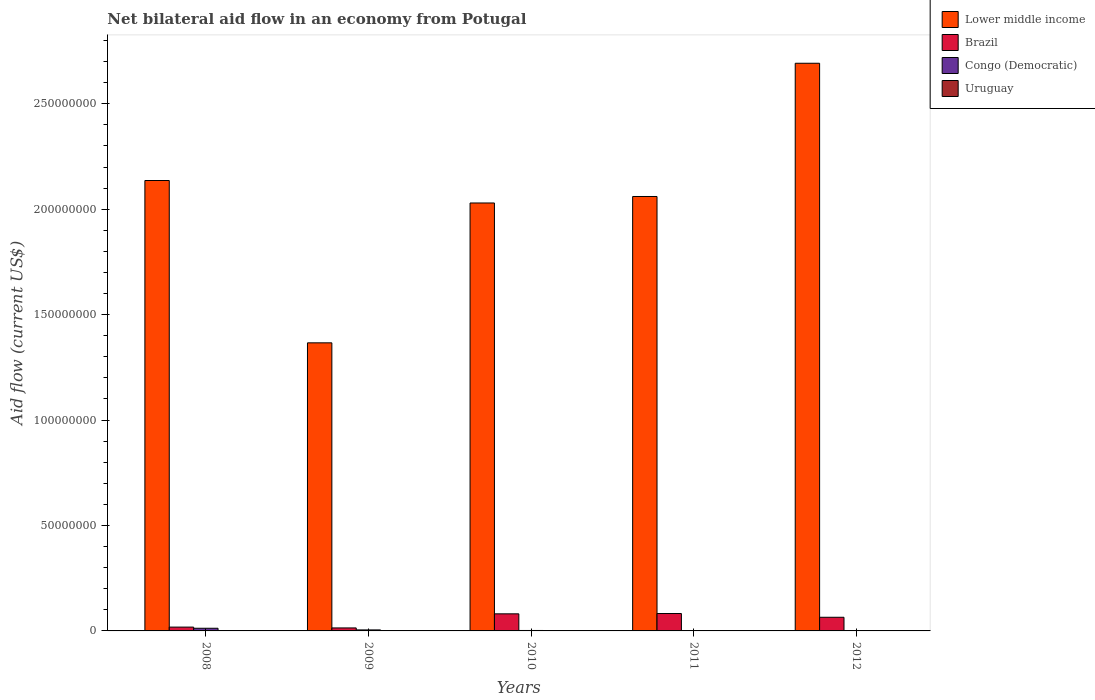How many different coloured bars are there?
Make the answer very short. 4. Are the number of bars on each tick of the X-axis equal?
Keep it short and to the point. Yes. How many bars are there on the 4th tick from the left?
Make the answer very short. 4. How many bars are there on the 3rd tick from the right?
Your response must be concise. 4. In how many cases, is the number of bars for a given year not equal to the number of legend labels?
Provide a succinct answer. 0. What is the net bilateral aid flow in Brazil in 2008?
Your response must be concise. 1.81e+06. Across all years, what is the maximum net bilateral aid flow in Congo (Democratic)?
Provide a short and direct response. 1.26e+06. In which year was the net bilateral aid flow in Congo (Democratic) maximum?
Your answer should be very brief. 2008. What is the total net bilateral aid flow in Uruguay in the graph?
Ensure brevity in your answer.  3.70e+05. What is the difference between the net bilateral aid flow in Lower middle income in 2008 and that in 2010?
Your response must be concise. 1.07e+07. What is the difference between the net bilateral aid flow in Lower middle income in 2008 and the net bilateral aid flow in Brazil in 2010?
Make the answer very short. 2.06e+08. What is the average net bilateral aid flow in Brazil per year?
Offer a very short reply. 5.21e+06. In the year 2011, what is the difference between the net bilateral aid flow in Uruguay and net bilateral aid flow in Lower middle income?
Offer a terse response. -2.06e+08. What is the ratio of the net bilateral aid flow in Lower middle income in 2011 to that in 2012?
Ensure brevity in your answer.  0.77. What is the difference between the highest and the second highest net bilateral aid flow in Uruguay?
Give a very brief answer. 2.00e+04. Is it the case that in every year, the sum of the net bilateral aid flow in Lower middle income and net bilateral aid flow in Uruguay is greater than the sum of net bilateral aid flow in Congo (Democratic) and net bilateral aid flow in Brazil?
Offer a terse response. No. What does the 3rd bar from the left in 2011 represents?
Make the answer very short. Congo (Democratic). What does the 1st bar from the right in 2009 represents?
Provide a succinct answer. Uruguay. Are all the bars in the graph horizontal?
Offer a terse response. No. How many years are there in the graph?
Ensure brevity in your answer.  5. What is the difference between two consecutive major ticks on the Y-axis?
Keep it short and to the point. 5.00e+07. Are the values on the major ticks of Y-axis written in scientific E-notation?
Provide a succinct answer. No. Does the graph contain any zero values?
Keep it short and to the point. No. Does the graph contain grids?
Offer a very short reply. No. How many legend labels are there?
Your answer should be very brief. 4. What is the title of the graph?
Ensure brevity in your answer.  Net bilateral aid flow in an economy from Potugal. Does "Sierra Leone" appear as one of the legend labels in the graph?
Your answer should be compact. No. What is the label or title of the X-axis?
Give a very brief answer. Years. What is the Aid flow (current US$) of Lower middle income in 2008?
Offer a terse response. 2.14e+08. What is the Aid flow (current US$) of Brazil in 2008?
Provide a succinct answer. 1.81e+06. What is the Aid flow (current US$) of Congo (Democratic) in 2008?
Provide a short and direct response. 1.26e+06. What is the Aid flow (current US$) of Lower middle income in 2009?
Give a very brief answer. 1.37e+08. What is the Aid flow (current US$) of Brazil in 2009?
Your answer should be compact. 1.42e+06. What is the Aid flow (current US$) of Congo (Democratic) in 2009?
Keep it short and to the point. 4.80e+05. What is the Aid flow (current US$) of Uruguay in 2009?
Your answer should be very brief. 6.00e+04. What is the Aid flow (current US$) in Lower middle income in 2010?
Provide a succinct answer. 2.03e+08. What is the Aid flow (current US$) in Brazil in 2010?
Your answer should be compact. 8.10e+06. What is the Aid flow (current US$) of Lower middle income in 2011?
Your response must be concise. 2.06e+08. What is the Aid flow (current US$) in Brazil in 2011?
Your answer should be very brief. 8.25e+06. What is the Aid flow (current US$) of Uruguay in 2011?
Ensure brevity in your answer.  9.00e+04. What is the Aid flow (current US$) of Lower middle income in 2012?
Make the answer very short. 2.69e+08. What is the Aid flow (current US$) of Brazil in 2012?
Make the answer very short. 6.47e+06. What is the Aid flow (current US$) in Uruguay in 2012?
Offer a very short reply. 7.00e+04. Across all years, what is the maximum Aid flow (current US$) in Lower middle income?
Give a very brief answer. 2.69e+08. Across all years, what is the maximum Aid flow (current US$) in Brazil?
Provide a short and direct response. 8.25e+06. Across all years, what is the maximum Aid flow (current US$) of Congo (Democratic)?
Your answer should be compact. 1.26e+06. Across all years, what is the maximum Aid flow (current US$) in Uruguay?
Your response must be concise. 1.10e+05. Across all years, what is the minimum Aid flow (current US$) in Lower middle income?
Your answer should be compact. 1.37e+08. Across all years, what is the minimum Aid flow (current US$) of Brazil?
Keep it short and to the point. 1.42e+06. Across all years, what is the minimum Aid flow (current US$) of Congo (Democratic)?
Keep it short and to the point. 3.00e+04. What is the total Aid flow (current US$) of Lower middle income in the graph?
Keep it short and to the point. 1.03e+09. What is the total Aid flow (current US$) of Brazil in the graph?
Offer a very short reply. 2.60e+07. What is the total Aid flow (current US$) in Congo (Democratic) in the graph?
Your answer should be very brief. 2.02e+06. What is the difference between the Aid flow (current US$) of Lower middle income in 2008 and that in 2009?
Offer a very short reply. 7.70e+07. What is the difference between the Aid flow (current US$) of Brazil in 2008 and that in 2009?
Make the answer very short. 3.90e+05. What is the difference between the Aid flow (current US$) in Congo (Democratic) in 2008 and that in 2009?
Your answer should be very brief. 7.80e+05. What is the difference between the Aid flow (current US$) of Uruguay in 2008 and that in 2009?
Your answer should be very brief. 5.00e+04. What is the difference between the Aid flow (current US$) in Lower middle income in 2008 and that in 2010?
Provide a succinct answer. 1.07e+07. What is the difference between the Aid flow (current US$) of Brazil in 2008 and that in 2010?
Ensure brevity in your answer.  -6.29e+06. What is the difference between the Aid flow (current US$) in Congo (Democratic) in 2008 and that in 2010?
Offer a very short reply. 1.05e+06. What is the difference between the Aid flow (current US$) in Lower middle income in 2008 and that in 2011?
Provide a succinct answer. 7.58e+06. What is the difference between the Aid flow (current US$) of Brazil in 2008 and that in 2011?
Ensure brevity in your answer.  -6.44e+06. What is the difference between the Aid flow (current US$) in Congo (Democratic) in 2008 and that in 2011?
Provide a succinct answer. 1.23e+06. What is the difference between the Aid flow (current US$) of Uruguay in 2008 and that in 2011?
Your answer should be compact. 2.00e+04. What is the difference between the Aid flow (current US$) in Lower middle income in 2008 and that in 2012?
Provide a succinct answer. -5.56e+07. What is the difference between the Aid flow (current US$) in Brazil in 2008 and that in 2012?
Give a very brief answer. -4.66e+06. What is the difference between the Aid flow (current US$) of Congo (Democratic) in 2008 and that in 2012?
Ensure brevity in your answer.  1.22e+06. What is the difference between the Aid flow (current US$) in Uruguay in 2008 and that in 2012?
Make the answer very short. 4.00e+04. What is the difference between the Aid flow (current US$) in Lower middle income in 2009 and that in 2010?
Your response must be concise. -6.63e+07. What is the difference between the Aid flow (current US$) in Brazil in 2009 and that in 2010?
Offer a very short reply. -6.68e+06. What is the difference between the Aid flow (current US$) in Uruguay in 2009 and that in 2010?
Make the answer very short. 2.00e+04. What is the difference between the Aid flow (current US$) of Lower middle income in 2009 and that in 2011?
Provide a short and direct response. -6.94e+07. What is the difference between the Aid flow (current US$) of Brazil in 2009 and that in 2011?
Your answer should be compact. -6.83e+06. What is the difference between the Aid flow (current US$) of Congo (Democratic) in 2009 and that in 2011?
Provide a short and direct response. 4.50e+05. What is the difference between the Aid flow (current US$) of Lower middle income in 2009 and that in 2012?
Your answer should be very brief. -1.33e+08. What is the difference between the Aid flow (current US$) in Brazil in 2009 and that in 2012?
Keep it short and to the point. -5.05e+06. What is the difference between the Aid flow (current US$) of Lower middle income in 2010 and that in 2011?
Make the answer very short. -3.08e+06. What is the difference between the Aid flow (current US$) in Lower middle income in 2010 and that in 2012?
Offer a terse response. -6.63e+07. What is the difference between the Aid flow (current US$) of Brazil in 2010 and that in 2012?
Ensure brevity in your answer.  1.63e+06. What is the difference between the Aid flow (current US$) in Congo (Democratic) in 2010 and that in 2012?
Your answer should be very brief. 1.70e+05. What is the difference between the Aid flow (current US$) in Uruguay in 2010 and that in 2012?
Give a very brief answer. -3.00e+04. What is the difference between the Aid flow (current US$) in Lower middle income in 2011 and that in 2012?
Keep it short and to the point. -6.32e+07. What is the difference between the Aid flow (current US$) of Brazil in 2011 and that in 2012?
Keep it short and to the point. 1.78e+06. What is the difference between the Aid flow (current US$) of Congo (Democratic) in 2011 and that in 2012?
Provide a succinct answer. -10000. What is the difference between the Aid flow (current US$) of Uruguay in 2011 and that in 2012?
Provide a succinct answer. 2.00e+04. What is the difference between the Aid flow (current US$) in Lower middle income in 2008 and the Aid flow (current US$) in Brazil in 2009?
Make the answer very short. 2.12e+08. What is the difference between the Aid flow (current US$) of Lower middle income in 2008 and the Aid flow (current US$) of Congo (Democratic) in 2009?
Your response must be concise. 2.13e+08. What is the difference between the Aid flow (current US$) of Lower middle income in 2008 and the Aid flow (current US$) of Uruguay in 2009?
Give a very brief answer. 2.14e+08. What is the difference between the Aid flow (current US$) of Brazil in 2008 and the Aid flow (current US$) of Congo (Democratic) in 2009?
Offer a very short reply. 1.33e+06. What is the difference between the Aid flow (current US$) of Brazil in 2008 and the Aid flow (current US$) of Uruguay in 2009?
Your answer should be compact. 1.75e+06. What is the difference between the Aid flow (current US$) in Congo (Democratic) in 2008 and the Aid flow (current US$) in Uruguay in 2009?
Ensure brevity in your answer.  1.20e+06. What is the difference between the Aid flow (current US$) in Lower middle income in 2008 and the Aid flow (current US$) in Brazil in 2010?
Ensure brevity in your answer.  2.06e+08. What is the difference between the Aid flow (current US$) in Lower middle income in 2008 and the Aid flow (current US$) in Congo (Democratic) in 2010?
Offer a very short reply. 2.13e+08. What is the difference between the Aid flow (current US$) of Lower middle income in 2008 and the Aid flow (current US$) of Uruguay in 2010?
Your response must be concise. 2.14e+08. What is the difference between the Aid flow (current US$) in Brazil in 2008 and the Aid flow (current US$) in Congo (Democratic) in 2010?
Ensure brevity in your answer.  1.60e+06. What is the difference between the Aid flow (current US$) in Brazil in 2008 and the Aid flow (current US$) in Uruguay in 2010?
Keep it short and to the point. 1.77e+06. What is the difference between the Aid flow (current US$) of Congo (Democratic) in 2008 and the Aid flow (current US$) of Uruguay in 2010?
Your answer should be compact. 1.22e+06. What is the difference between the Aid flow (current US$) of Lower middle income in 2008 and the Aid flow (current US$) of Brazil in 2011?
Keep it short and to the point. 2.05e+08. What is the difference between the Aid flow (current US$) of Lower middle income in 2008 and the Aid flow (current US$) of Congo (Democratic) in 2011?
Offer a terse response. 2.14e+08. What is the difference between the Aid flow (current US$) of Lower middle income in 2008 and the Aid flow (current US$) of Uruguay in 2011?
Your answer should be very brief. 2.14e+08. What is the difference between the Aid flow (current US$) in Brazil in 2008 and the Aid flow (current US$) in Congo (Democratic) in 2011?
Give a very brief answer. 1.78e+06. What is the difference between the Aid flow (current US$) of Brazil in 2008 and the Aid flow (current US$) of Uruguay in 2011?
Offer a terse response. 1.72e+06. What is the difference between the Aid flow (current US$) of Congo (Democratic) in 2008 and the Aid flow (current US$) of Uruguay in 2011?
Make the answer very short. 1.17e+06. What is the difference between the Aid flow (current US$) of Lower middle income in 2008 and the Aid flow (current US$) of Brazil in 2012?
Your answer should be compact. 2.07e+08. What is the difference between the Aid flow (current US$) of Lower middle income in 2008 and the Aid flow (current US$) of Congo (Democratic) in 2012?
Make the answer very short. 2.14e+08. What is the difference between the Aid flow (current US$) of Lower middle income in 2008 and the Aid flow (current US$) of Uruguay in 2012?
Make the answer very short. 2.14e+08. What is the difference between the Aid flow (current US$) in Brazil in 2008 and the Aid flow (current US$) in Congo (Democratic) in 2012?
Offer a very short reply. 1.77e+06. What is the difference between the Aid flow (current US$) of Brazil in 2008 and the Aid flow (current US$) of Uruguay in 2012?
Offer a very short reply. 1.74e+06. What is the difference between the Aid flow (current US$) in Congo (Democratic) in 2008 and the Aid flow (current US$) in Uruguay in 2012?
Give a very brief answer. 1.19e+06. What is the difference between the Aid flow (current US$) in Lower middle income in 2009 and the Aid flow (current US$) in Brazil in 2010?
Offer a terse response. 1.29e+08. What is the difference between the Aid flow (current US$) in Lower middle income in 2009 and the Aid flow (current US$) in Congo (Democratic) in 2010?
Offer a terse response. 1.36e+08. What is the difference between the Aid flow (current US$) of Lower middle income in 2009 and the Aid flow (current US$) of Uruguay in 2010?
Ensure brevity in your answer.  1.37e+08. What is the difference between the Aid flow (current US$) of Brazil in 2009 and the Aid flow (current US$) of Congo (Democratic) in 2010?
Make the answer very short. 1.21e+06. What is the difference between the Aid flow (current US$) in Brazil in 2009 and the Aid flow (current US$) in Uruguay in 2010?
Your answer should be compact. 1.38e+06. What is the difference between the Aid flow (current US$) of Congo (Democratic) in 2009 and the Aid flow (current US$) of Uruguay in 2010?
Provide a succinct answer. 4.40e+05. What is the difference between the Aid flow (current US$) of Lower middle income in 2009 and the Aid flow (current US$) of Brazil in 2011?
Make the answer very short. 1.28e+08. What is the difference between the Aid flow (current US$) in Lower middle income in 2009 and the Aid flow (current US$) in Congo (Democratic) in 2011?
Your answer should be compact. 1.37e+08. What is the difference between the Aid flow (current US$) of Lower middle income in 2009 and the Aid flow (current US$) of Uruguay in 2011?
Your answer should be compact. 1.37e+08. What is the difference between the Aid flow (current US$) in Brazil in 2009 and the Aid flow (current US$) in Congo (Democratic) in 2011?
Make the answer very short. 1.39e+06. What is the difference between the Aid flow (current US$) in Brazil in 2009 and the Aid flow (current US$) in Uruguay in 2011?
Keep it short and to the point. 1.33e+06. What is the difference between the Aid flow (current US$) in Congo (Democratic) in 2009 and the Aid flow (current US$) in Uruguay in 2011?
Keep it short and to the point. 3.90e+05. What is the difference between the Aid flow (current US$) in Lower middle income in 2009 and the Aid flow (current US$) in Brazil in 2012?
Keep it short and to the point. 1.30e+08. What is the difference between the Aid flow (current US$) of Lower middle income in 2009 and the Aid flow (current US$) of Congo (Democratic) in 2012?
Keep it short and to the point. 1.37e+08. What is the difference between the Aid flow (current US$) of Lower middle income in 2009 and the Aid flow (current US$) of Uruguay in 2012?
Your response must be concise. 1.37e+08. What is the difference between the Aid flow (current US$) in Brazil in 2009 and the Aid flow (current US$) in Congo (Democratic) in 2012?
Offer a terse response. 1.38e+06. What is the difference between the Aid flow (current US$) in Brazil in 2009 and the Aid flow (current US$) in Uruguay in 2012?
Your answer should be very brief. 1.35e+06. What is the difference between the Aid flow (current US$) in Lower middle income in 2010 and the Aid flow (current US$) in Brazil in 2011?
Ensure brevity in your answer.  1.95e+08. What is the difference between the Aid flow (current US$) of Lower middle income in 2010 and the Aid flow (current US$) of Congo (Democratic) in 2011?
Your answer should be compact. 2.03e+08. What is the difference between the Aid flow (current US$) in Lower middle income in 2010 and the Aid flow (current US$) in Uruguay in 2011?
Make the answer very short. 2.03e+08. What is the difference between the Aid flow (current US$) of Brazil in 2010 and the Aid flow (current US$) of Congo (Democratic) in 2011?
Keep it short and to the point. 8.07e+06. What is the difference between the Aid flow (current US$) of Brazil in 2010 and the Aid flow (current US$) of Uruguay in 2011?
Ensure brevity in your answer.  8.01e+06. What is the difference between the Aid flow (current US$) of Congo (Democratic) in 2010 and the Aid flow (current US$) of Uruguay in 2011?
Your answer should be compact. 1.20e+05. What is the difference between the Aid flow (current US$) in Lower middle income in 2010 and the Aid flow (current US$) in Brazil in 2012?
Your answer should be compact. 1.96e+08. What is the difference between the Aid flow (current US$) of Lower middle income in 2010 and the Aid flow (current US$) of Congo (Democratic) in 2012?
Your response must be concise. 2.03e+08. What is the difference between the Aid flow (current US$) in Lower middle income in 2010 and the Aid flow (current US$) in Uruguay in 2012?
Ensure brevity in your answer.  2.03e+08. What is the difference between the Aid flow (current US$) of Brazil in 2010 and the Aid flow (current US$) of Congo (Democratic) in 2012?
Ensure brevity in your answer.  8.06e+06. What is the difference between the Aid flow (current US$) in Brazil in 2010 and the Aid flow (current US$) in Uruguay in 2012?
Keep it short and to the point. 8.03e+06. What is the difference between the Aid flow (current US$) in Lower middle income in 2011 and the Aid flow (current US$) in Brazil in 2012?
Keep it short and to the point. 2.00e+08. What is the difference between the Aid flow (current US$) of Lower middle income in 2011 and the Aid flow (current US$) of Congo (Democratic) in 2012?
Keep it short and to the point. 2.06e+08. What is the difference between the Aid flow (current US$) of Lower middle income in 2011 and the Aid flow (current US$) of Uruguay in 2012?
Keep it short and to the point. 2.06e+08. What is the difference between the Aid flow (current US$) of Brazil in 2011 and the Aid flow (current US$) of Congo (Democratic) in 2012?
Offer a very short reply. 8.21e+06. What is the difference between the Aid flow (current US$) of Brazil in 2011 and the Aid flow (current US$) of Uruguay in 2012?
Give a very brief answer. 8.18e+06. What is the difference between the Aid flow (current US$) in Congo (Democratic) in 2011 and the Aid flow (current US$) in Uruguay in 2012?
Your response must be concise. -4.00e+04. What is the average Aid flow (current US$) of Lower middle income per year?
Your answer should be very brief. 2.06e+08. What is the average Aid flow (current US$) in Brazil per year?
Offer a very short reply. 5.21e+06. What is the average Aid flow (current US$) in Congo (Democratic) per year?
Keep it short and to the point. 4.04e+05. What is the average Aid flow (current US$) in Uruguay per year?
Your answer should be very brief. 7.40e+04. In the year 2008, what is the difference between the Aid flow (current US$) of Lower middle income and Aid flow (current US$) of Brazil?
Provide a succinct answer. 2.12e+08. In the year 2008, what is the difference between the Aid flow (current US$) in Lower middle income and Aid flow (current US$) in Congo (Democratic)?
Offer a very short reply. 2.12e+08. In the year 2008, what is the difference between the Aid flow (current US$) in Lower middle income and Aid flow (current US$) in Uruguay?
Make the answer very short. 2.13e+08. In the year 2008, what is the difference between the Aid flow (current US$) of Brazil and Aid flow (current US$) of Congo (Democratic)?
Give a very brief answer. 5.50e+05. In the year 2008, what is the difference between the Aid flow (current US$) in Brazil and Aid flow (current US$) in Uruguay?
Make the answer very short. 1.70e+06. In the year 2008, what is the difference between the Aid flow (current US$) of Congo (Democratic) and Aid flow (current US$) of Uruguay?
Ensure brevity in your answer.  1.15e+06. In the year 2009, what is the difference between the Aid flow (current US$) of Lower middle income and Aid flow (current US$) of Brazil?
Provide a succinct answer. 1.35e+08. In the year 2009, what is the difference between the Aid flow (current US$) in Lower middle income and Aid flow (current US$) in Congo (Democratic)?
Offer a very short reply. 1.36e+08. In the year 2009, what is the difference between the Aid flow (current US$) of Lower middle income and Aid flow (current US$) of Uruguay?
Offer a very short reply. 1.37e+08. In the year 2009, what is the difference between the Aid flow (current US$) of Brazil and Aid flow (current US$) of Congo (Democratic)?
Your response must be concise. 9.40e+05. In the year 2009, what is the difference between the Aid flow (current US$) of Brazil and Aid flow (current US$) of Uruguay?
Ensure brevity in your answer.  1.36e+06. In the year 2009, what is the difference between the Aid flow (current US$) of Congo (Democratic) and Aid flow (current US$) of Uruguay?
Make the answer very short. 4.20e+05. In the year 2010, what is the difference between the Aid flow (current US$) in Lower middle income and Aid flow (current US$) in Brazil?
Keep it short and to the point. 1.95e+08. In the year 2010, what is the difference between the Aid flow (current US$) in Lower middle income and Aid flow (current US$) in Congo (Democratic)?
Your response must be concise. 2.03e+08. In the year 2010, what is the difference between the Aid flow (current US$) in Lower middle income and Aid flow (current US$) in Uruguay?
Your answer should be compact. 2.03e+08. In the year 2010, what is the difference between the Aid flow (current US$) in Brazil and Aid flow (current US$) in Congo (Democratic)?
Offer a terse response. 7.89e+06. In the year 2010, what is the difference between the Aid flow (current US$) of Brazil and Aid flow (current US$) of Uruguay?
Your answer should be very brief. 8.06e+06. In the year 2011, what is the difference between the Aid flow (current US$) of Lower middle income and Aid flow (current US$) of Brazil?
Make the answer very short. 1.98e+08. In the year 2011, what is the difference between the Aid flow (current US$) in Lower middle income and Aid flow (current US$) in Congo (Democratic)?
Keep it short and to the point. 2.06e+08. In the year 2011, what is the difference between the Aid flow (current US$) in Lower middle income and Aid flow (current US$) in Uruguay?
Give a very brief answer. 2.06e+08. In the year 2011, what is the difference between the Aid flow (current US$) in Brazil and Aid flow (current US$) in Congo (Democratic)?
Offer a terse response. 8.22e+06. In the year 2011, what is the difference between the Aid flow (current US$) in Brazil and Aid flow (current US$) in Uruguay?
Your answer should be compact. 8.16e+06. In the year 2011, what is the difference between the Aid flow (current US$) of Congo (Democratic) and Aid flow (current US$) of Uruguay?
Keep it short and to the point. -6.00e+04. In the year 2012, what is the difference between the Aid flow (current US$) in Lower middle income and Aid flow (current US$) in Brazil?
Your response must be concise. 2.63e+08. In the year 2012, what is the difference between the Aid flow (current US$) of Lower middle income and Aid flow (current US$) of Congo (Democratic)?
Your answer should be compact. 2.69e+08. In the year 2012, what is the difference between the Aid flow (current US$) in Lower middle income and Aid flow (current US$) in Uruguay?
Provide a succinct answer. 2.69e+08. In the year 2012, what is the difference between the Aid flow (current US$) in Brazil and Aid flow (current US$) in Congo (Democratic)?
Your answer should be very brief. 6.43e+06. In the year 2012, what is the difference between the Aid flow (current US$) in Brazil and Aid flow (current US$) in Uruguay?
Provide a succinct answer. 6.40e+06. In the year 2012, what is the difference between the Aid flow (current US$) of Congo (Democratic) and Aid flow (current US$) of Uruguay?
Offer a terse response. -3.00e+04. What is the ratio of the Aid flow (current US$) of Lower middle income in 2008 to that in 2009?
Offer a very short reply. 1.56. What is the ratio of the Aid flow (current US$) in Brazil in 2008 to that in 2009?
Provide a succinct answer. 1.27. What is the ratio of the Aid flow (current US$) in Congo (Democratic) in 2008 to that in 2009?
Keep it short and to the point. 2.62. What is the ratio of the Aid flow (current US$) in Uruguay in 2008 to that in 2009?
Give a very brief answer. 1.83. What is the ratio of the Aid flow (current US$) in Lower middle income in 2008 to that in 2010?
Your answer should be very brief. 1.05. What is the ratio of the Aid flow (current US$) of Brazil in 2008 to that in 2010?
Make the answer very short. 0.22. What is the ratio of the Aid flow (current US$) of Uruguay in 2008 to that in 2010?
Offer a very short reply. 2.75. What is the ratio of the Aid flow (current US$) of Lower middle income in 2008 to that in 2011?
Give a very brief answer. 1.04. What is the ratio of the Aid flow (current US$) in Brazil in 2008 to that in 2011?
Make the answer very short. 0.22. What is the ratio of the Aid flow (current US$) of Uruguay in 2008 to that in 2011?
Make the answer very short. 1.22. What is the ratio of the Aid flow (current US$) in Lower middle income in 2008 to that in 2012?
Your response must be concise. 0.79. What is the ratio of the Aid flow (current US$) of Brazil in 2008 to that in 2012?
Provide a short and direct response. 0.28. What is the ratio of the Aid flow (current US$) in Congo (Democratic) in 2008 to that in 2012?
Your answer should be compact. 31.5. What is the ratio of the Aid flow (current US$) in Uruguay in 2008 to that in 2012?
Your answer should be very brief. 1.57. What is the ratio of the Aid flow (current US$) in Lower middle income in 2009 to that in 2010?
Keep it short and to the point. 0.67. What is the ratio of the Aid flow (current US$) of Brazil in 2009 to that in 2010?
Your answer should be compact. 0.18. What is the ratio of the Aid flow (current US$) in Congo (Democratic) in 2009 to that in 2010?
Keep it short and to the point. 2.29. What is the ratio of the Aid flow (current US$) of Uruguay in 2009 to that in 2010?
Ensure brevity in your answer.  1.5. What is the ratio of the Aid flow (current US$) of Lower middle income in 2009 to that in 2011?
Offer a terse response. 0.66. What is the ratio of the Aid flow (current US$) of Brazil in 2009 to that in 2011?
Provide a short and direct response. 0.17. What is the ratio of the Aid flow (current US$) of Congo (Democratic) in 2009 to that in 2011?
Your response must be concise. 16. What is the ratio of the Aid flow (current US$) of Lower middle income in 2009 to that in 2012?
Offer a terse response. 0.51. What is the ratio of the Aid flow (current US$) in Brazil in 2009 to that in 2012?
Ensure brevity in your answer.  0.22. What is the ratio of the Aid flow (current US$) in Congo (Democratic) in 2009 to that in 2012?
Make the answer very short. 12. What is the ratio of the Aid flow (current US$) of Brazil in 2010 to that in 2011?
Provide a short and direct response. 0.98. What is the ratio of the Aid flow (current US$) in Uruguay in 2010 to that in 2011?
Offer a terse response. 0.44. What is the ratio of the Aid flow (current US$) of Lower middle income in 2010 to that in 2012?
Offer a very short reply. 0.75. What is the ratio of the Aid flow (current US$) of Brazil in 2010 to that in 2012?
Give a very brief answer. 1.25. What is the ratio of the Aid flow (current US$) of Congo (Democratic) in 2010 to that in 2012?
Your response must be concise. 5.25. What is the ratio of the Aid flow (current US$) of Lower middle income in 2011 to that in 2012?
Keep it short and to the point. 0.77. What is the ratio of the Aid flow (current US$) in Brazil in 2011 to that in 2012?
Offer a very short reply. 1.28. What is the ratio of the Aid flow (current US$) in Congo (Democratic) in 2011 to that in 2012?
Make the answer very short. 0.75. What is the ratio of the Aid flow (current US$) in Uruguay in 2011 to that in 2012?
Ensure brevity in your answer.  1.29. What is the difference between the highest and the second highest Aid flow (current US$) of Lower middle income?
Your answer should be very brief. 5.56e+07. What is the difference between the highest and the second highest Aid flow (current US$) in Congo (Democratic)?
Make the answer very short. 7.80e+05. What is the difference between the highest and the second highest Aid flow (current US$) in Uruguay?
Keep it short and to the point. 2.00e+04. What is the difference between the highest and the lowest Aid flow (current US$) of Lower middle income?
Offer a terse response. 1.33e+08. What is the difference between the highest and the lowest Aid flow (current US$) in Brazil?
Your answer should be very brief. 6.83e+06. What is the difference between the highest and the lowest Aid flow (current US$) in Congo (Democratic)?
Your answer should be compact. 1.23e+06. What is the difference between the highest and the lowest Aid flow (current US$) of Uruguay?
Make the answer very short. 7.00e+04. 